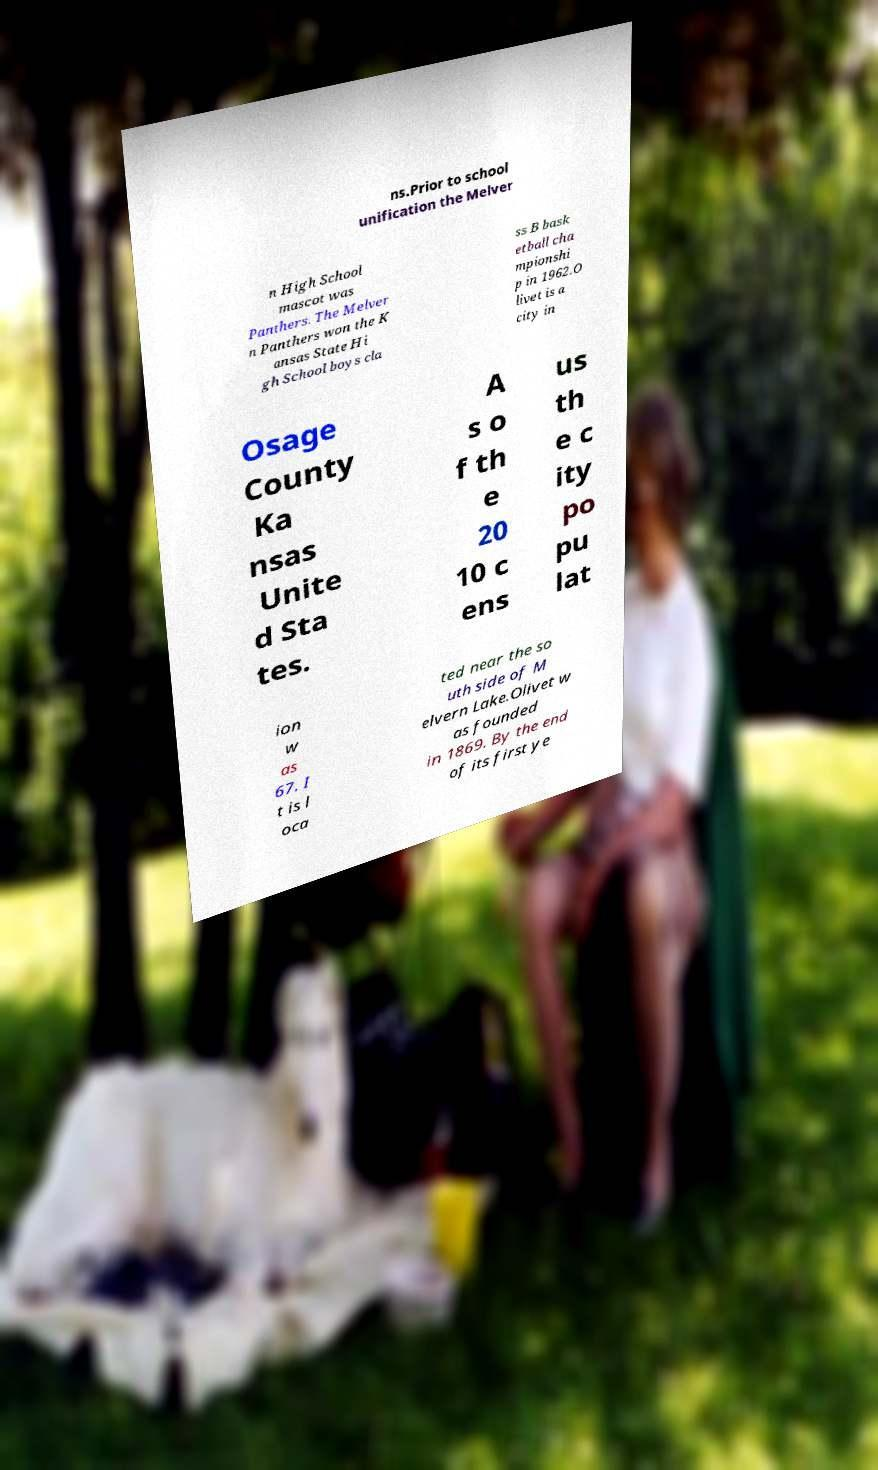For documentation purposes, I need the text within this image transcribed. Could you provide that? ns.Prior to school unification the Melver n High School mascot was Panthers. The Melver n Panthers won the K ansas State Hi gh School boys cla ss B bask etball cha mpionshi p in 1962.O livet is a city in Osage County Ka nsas Unite d Sta tes. A s o f th e 20 10 c ens us th e c ity po pu lat ion w as 67. I t is l oca ted near the so uth side of M elvern Lake.Olivet w as founded in 1869. By the end of its first ye 